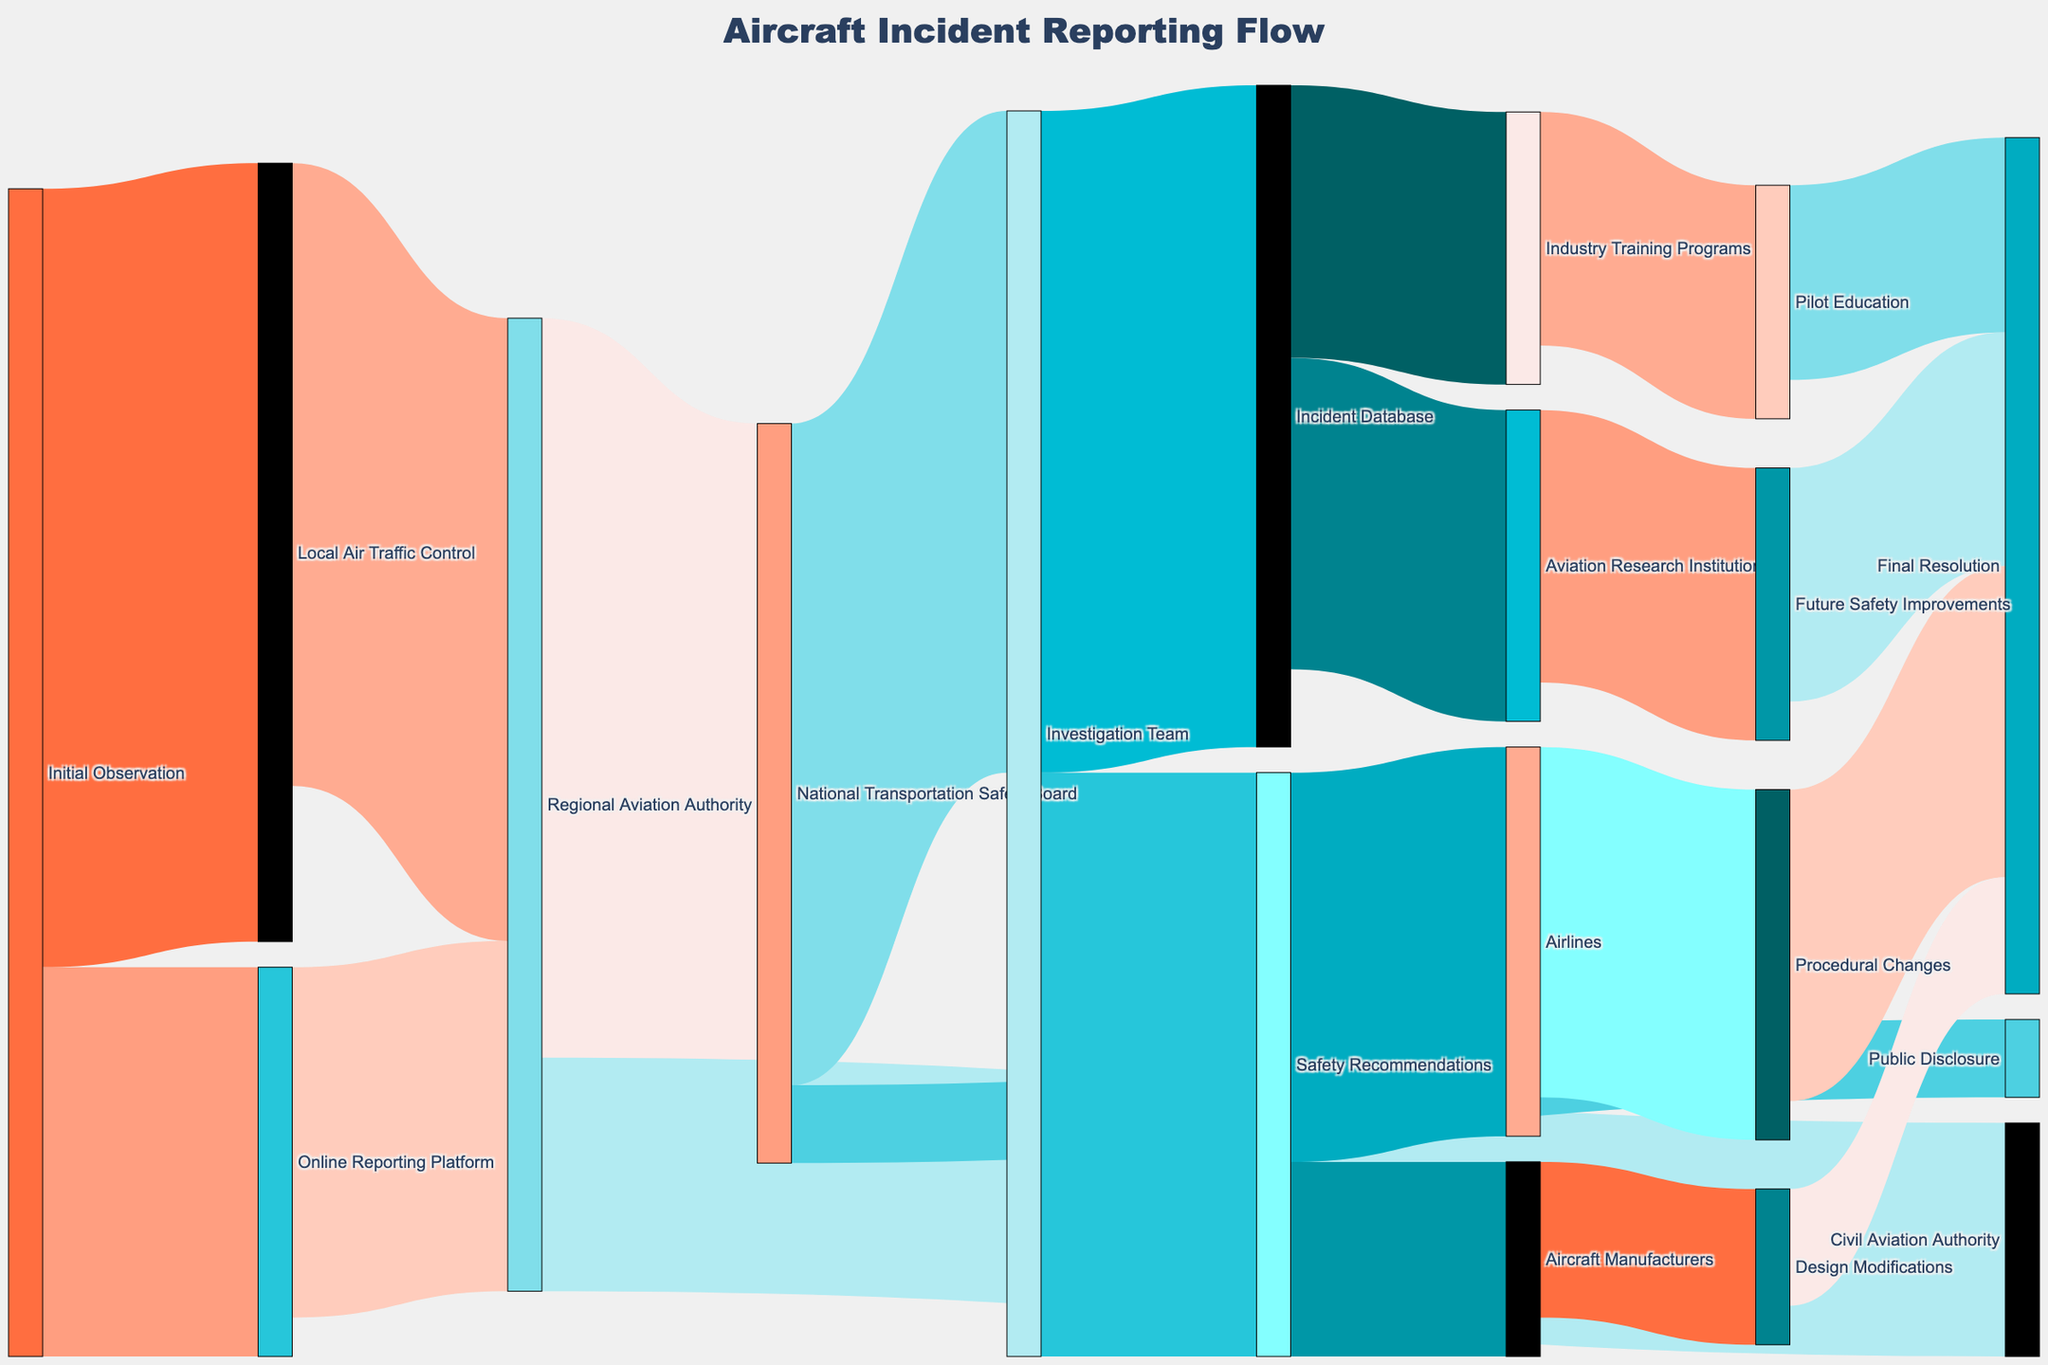What is the title of the Sankey Diagram? The title of a diagram is typically displayed prominently at the top or center of the visual. For this Sankey Diagram, the title is "Aircraft Incident Reporting Flow."
Answer: Aircraft Incident Reporting Flow How many different entities are involved in the flow from initial observation to final resolution? To determine the number of entities, count the distinct nodes labeled in the diagram. This includes the start, intermediary, and end points of the flow. By counting these nodes, we find there are 18 different entities involved.
Answer: 18 Which path has the highest value from Initial Observation? To find the path with the highest value, compare the values of the flows originating from "Initial Observation." The flows are to "Local Air Traffic Control" (100) and "Online Reporting Platform" (50). The highest value is to "Local Air Traffic Control."
Answer: Local Air Traffic Control (100) How many entities are directly connected to the Regional Aviation Authority? The Regional Aviation Authority has connections coming in and going out. Count the entities connected both as sources and targets. There are connections from "Local Air Traffic Control," "Online Reporting Platform," "National Transportation Safety Board," and "Civil Aviation Authority." So, there are 4 connections.
Answer: 4 What is the combined value flowing into the Investigation Team? Add the values of the paths leading into the Investigation Team, which are from the National Transportation Safety Board (85).
Answer: 85 Through which entity does the majority of the flow of local air traffic control incidents end up at the final resolution? Track the major flows from "Local Air Traffic Control" through intermediary steps until ending at "Final Resolution." The path is: Local Air Traffic Control (80) -> Regional Aviation Authority (95) -> National Transportation Safety Board -> Investigation Team (85) -> Safety Recommendations -> Airlines (50) -> Procedural Changes (45) -> Final Resolution.
Answer: Procedural Changes What percentage of the incidents reported to the National Transportation Safety Board are ultimately disclosed to the public? To find the percentage, divide the value of the incidents disclosed to the public by the total incidents received by the National Transportation Safety Board and multiply by 100%. The values are 10 (Public Disclosure) out of 95 (total from Regional Aviation Authority). The calculation is (10/95) * 100 = 10.53%.
Answer: 10.53% How does the number of values flowing into "Final Resolution" through Pilot Education compare to those through Procedural Changes? Check the values of the flows into "Final Resolution" from both "Pilot Education" and "Procedural Changes." Pilot Education has a flow value of 25, whereas Procedural Changes have a flow value of 40. Therefore, the value through Procedural Changes is higher.
Answer: Procedural Changes > Pilot Education (40 vs. 25) What are the final destinations for flows originating from Investigation Team? Examine the flows originating from the Investigation Team, which lead to Safety Recommendations (75) and Incident Database (85). Then further trace these paths. Safety Recommendations lead to Airlines and Aircraft Manufacturers, while Incident Database leads to Aviation Research Institutions and Industry Training Programs.
Answer: Airlines, Aircraft Manufacturers, Aviation Research Institutions, Industry Training Programs 